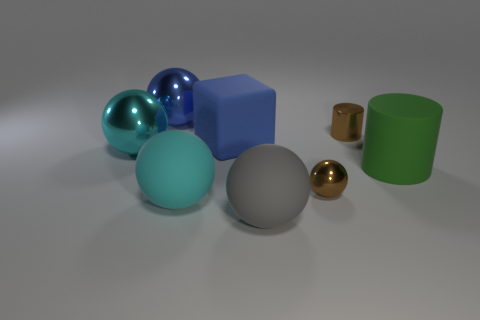Does the big object to the right of the gray matte sphere have the same color as the tiny thing on the left side of the tiny brown cylinder? No, the big object to the right of the gray matte sphere, which appears to be a glossy teal sphere, does not have the same color as the tiny object on the left side of the tiny brown cylinder, which is a small gold-colored sphere. The teal sphere has a cool, bluish-green hue, while the gold sphere radiates a warm, metallic yellow. 